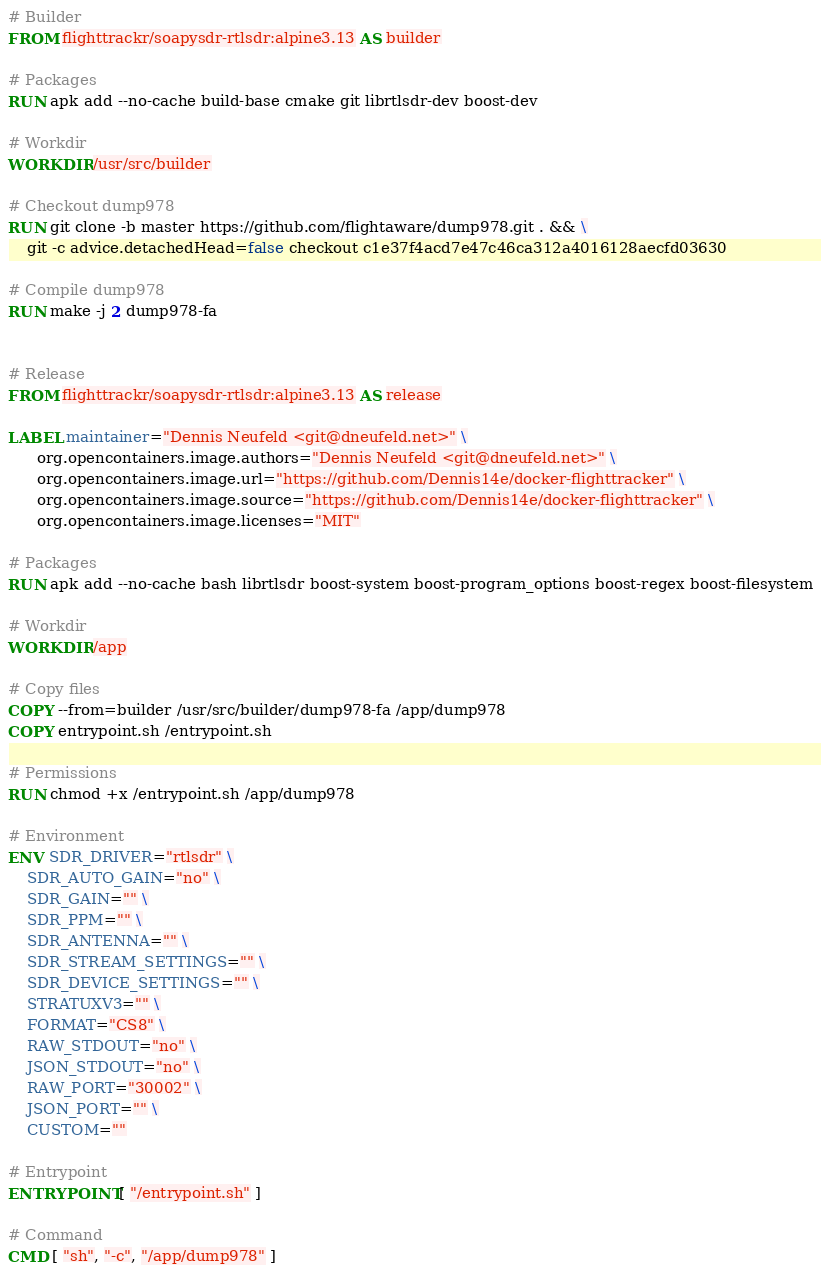<code> <loc_0><loc_0><loc_500><loc_500><_Dockerfile_># Builder
FROM flighttrackr/soapysdr-rtlsdr:alpine3.13 AS builder

# Packages
RUN apk add --no-cache build-base cmake git librtlsdr-dev boost-dev

# Workdir
WORKDIR /usr/src/builder

# Checkout dump978
RUN git clone -b master https://github.com/flightaware/dump978.git . && \
    git -c advice.detachedHead=false checkout c1e37f4acd7e47c46ca312a4016128aecfd03630

# Compile dump978
RUN make -j 2 dump978-fa


# Release
FROM flighttrackr/soapysdr-rtlsdr:alpine3.13 AS release

LABEL maintainer="Dennis Neufeld <git@dneufeld.net>" \
      org.opencontainers.image.authors="Dennis Neufeld <git@dneufeld.net>" \
      org.opencontainers.image.url="https://github.com/Dennis14e/docker-flighttracker" \
      org.opencontainers.image.source="https://github.com/Dennis14e/docker-flighttracker" \
      org.opencontainers.image.licenses="MIT"

# Packages
RUN apk add --no-cache bash librtlsdr boost-system boost-program_options boost-regex boost-filesystem

# Workdir
WORKDIR /app

# Copy files
COPY --from=builder /usr/src/builder/dump978-fa /app/dump978
COPY entrypoint.sh /entrypoint.sh

# Permissions
RUN chmod +x /entrypoint.sh /app/dump978

# Environment
ENV SDR_DRIVER="rtlsdr" \
    SDR_AUTO_GAIN="no" \
    SDR_GAIN="" \
    SDR_PPM="" \
    SDR_ANTENNA="" \
    SDR_STREAM_SETTINGS="" \
    SDR_DEVICE_SETTINGS="" \
    STRATUXV3="" \
    FORMAT="CS8" \
    RAW_STDOUT="no" \
    JSON_STDOUT="no" \
    RAW_PORT="30002" \
    JSON_PORT="" \
    CUSTOM=""

# Entrypoint
ENTRYPOINT [ "/entrypoint.sh" ]

# Command
CMD [ "sh", "-c", "/app/dump978" ]
</code> 